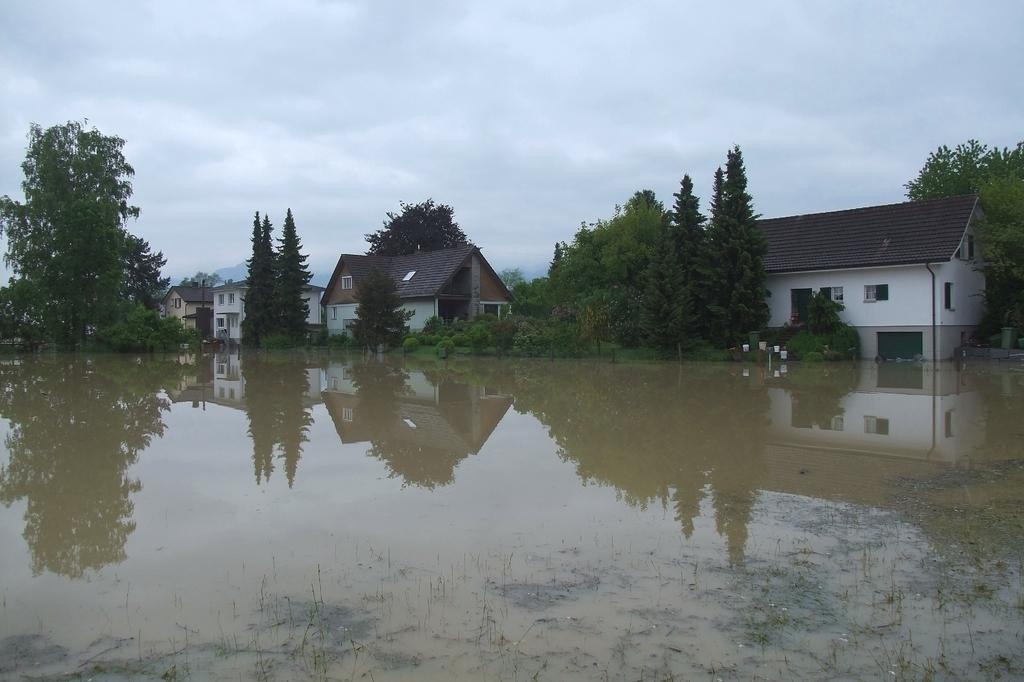What type of structures can be seen in the image? There are houses in the image. What type of vegetation is present in the image? There are plants and trees in the image. What is visible in the sky in the image? The sky is visible in the image. What type of natural feature can be seen in the image? There is a lake in the image. What type of memory can be seen floating in the lake in the image? There is no memory present in the image, and the lake does not contain any floating objects. What type of boundary can be seen surrounding the houses in the image? There is no boundary surrounding the houses in the image; they are simply situated in the landscape. 